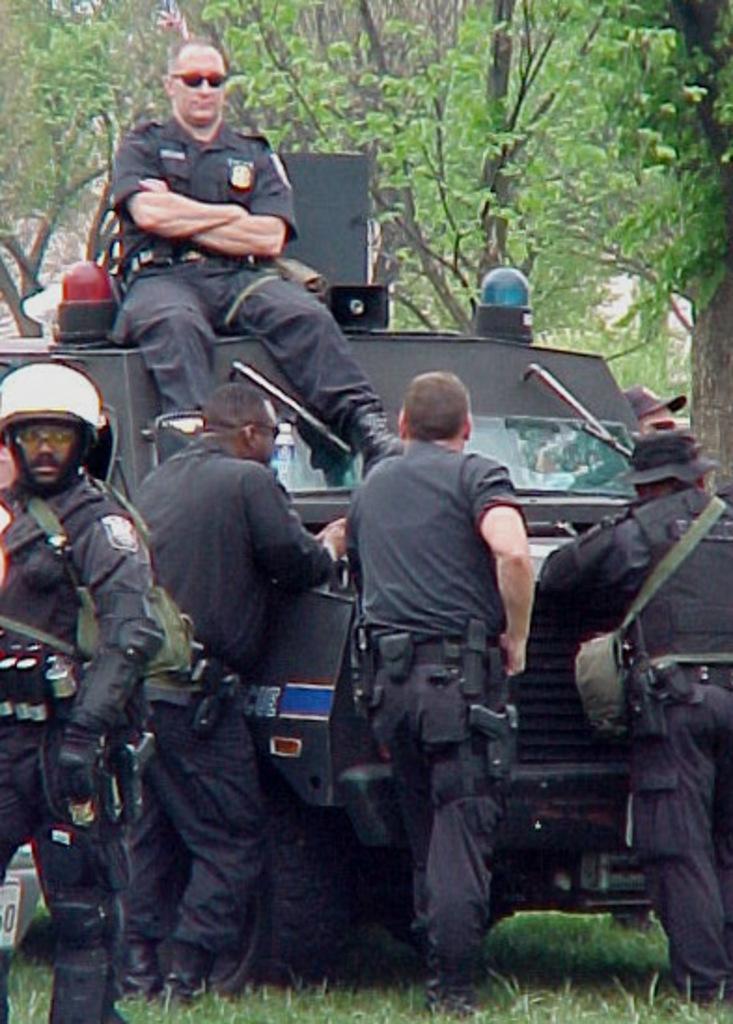In one or two sentences, can you explain what this image depicts? There are four persons standing and wearing a uniform at the bottom of this image. The person standing on the left side is wearing a white color helmet, and there is a vehicle in the background. There is one person sitting on this vehicle, and we can see there are some trees at the top of this image. 